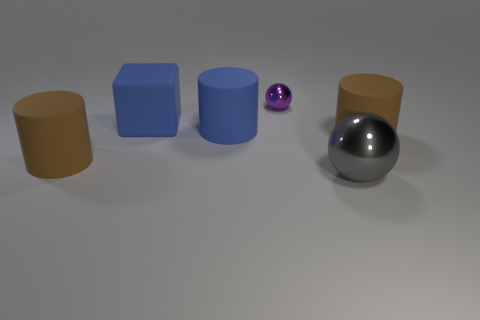Add 3 blocks. How many objects exist? 9 Subtract all spheres. How many objects are left? 4 Add 4 green cubes. How many green cubes exist? 4 Subtract 2 brown cylinders. How many objects are left? 4 Subtract all gray objects. Subtract all large spheres. How many objects are left? 4 Add 1 large balls. How many large balls are left? 2 